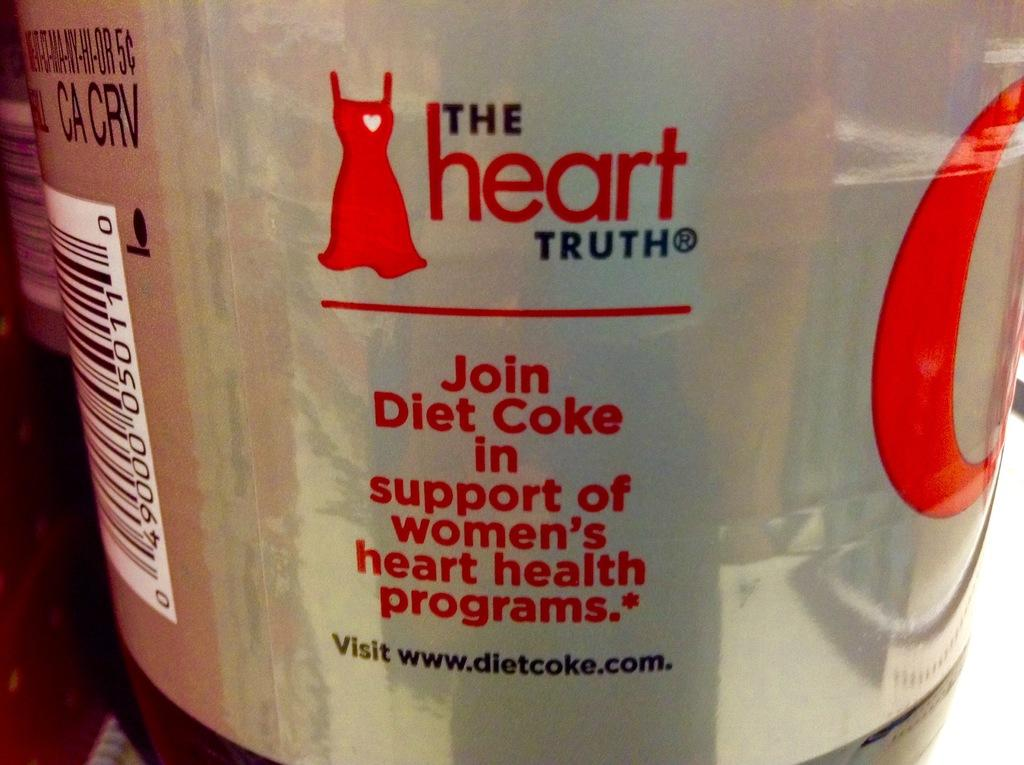<image>
Give a short and clear explanation of the subsequent image. A bottle's label describes "the heart truth" and invites you to join Diet Coke to support women's heart health. 